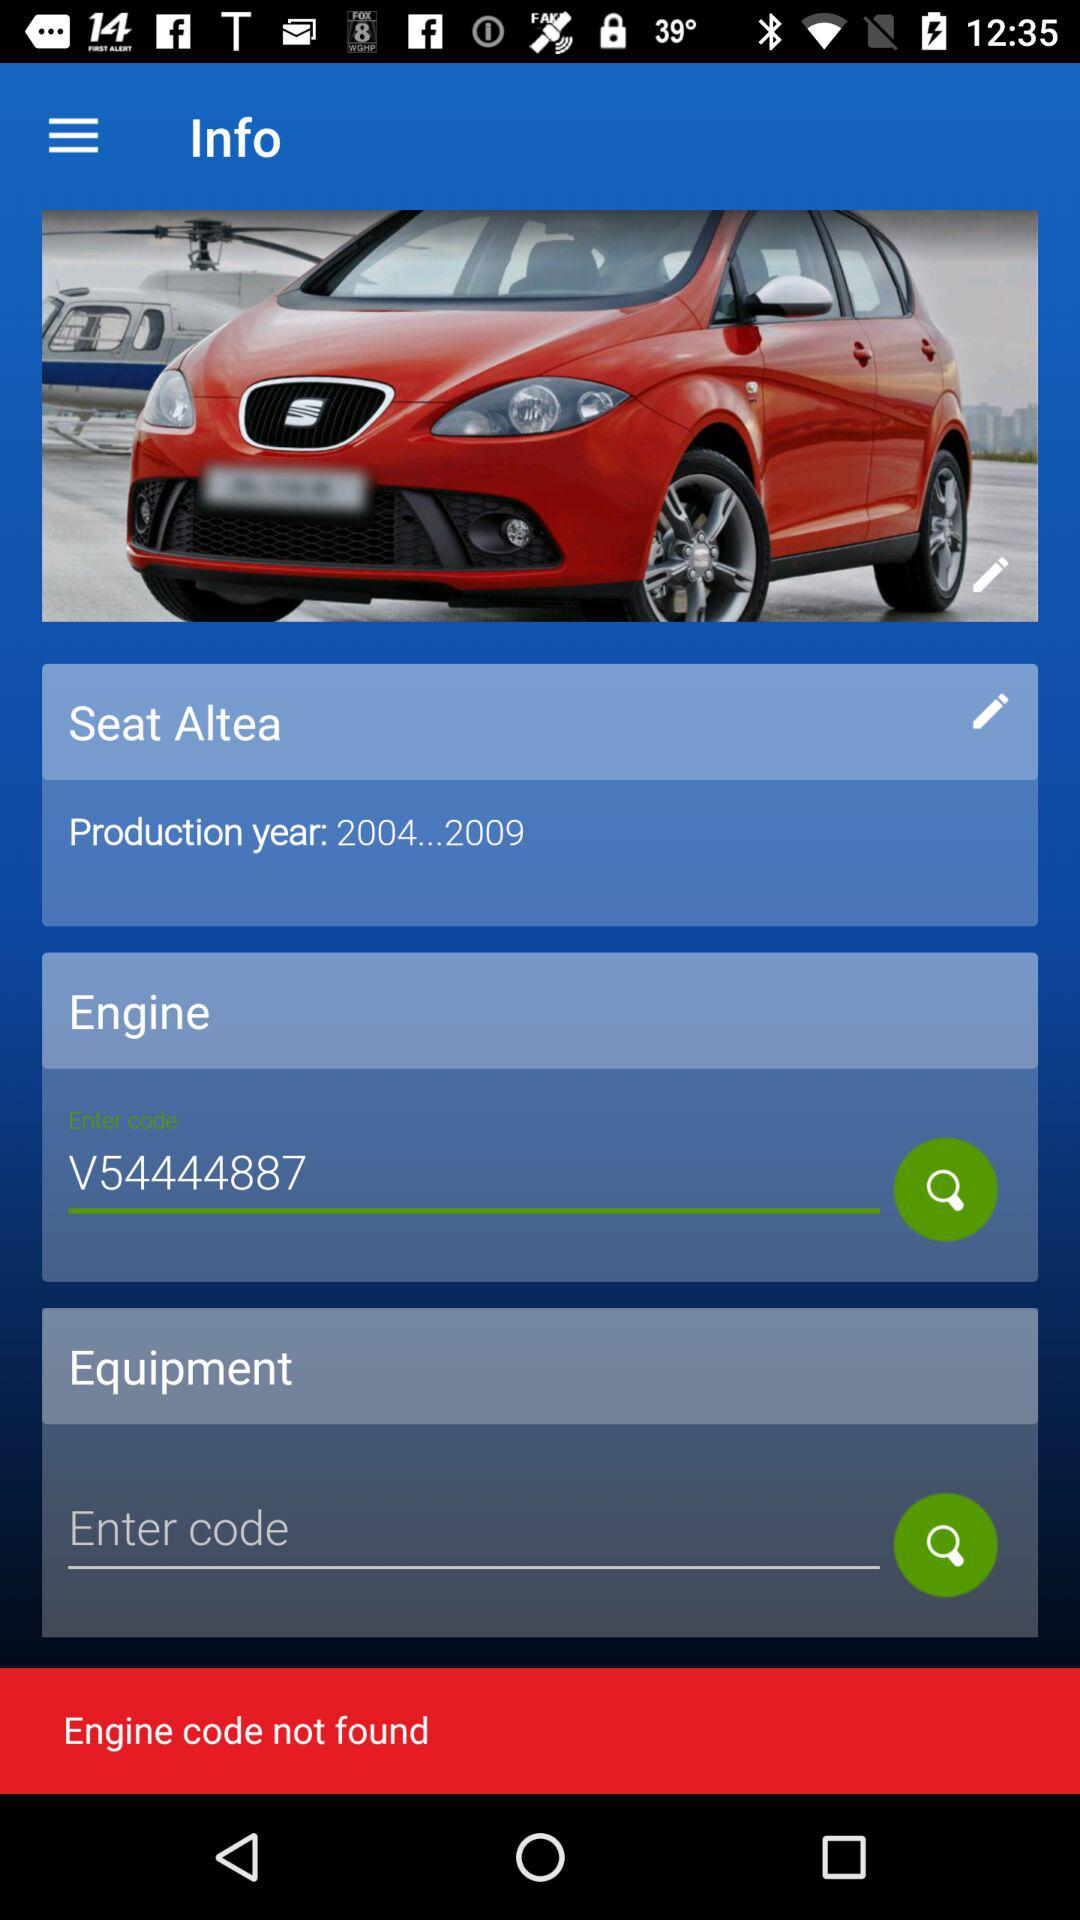What is the production year? The production year is from 2004 to 2009. 